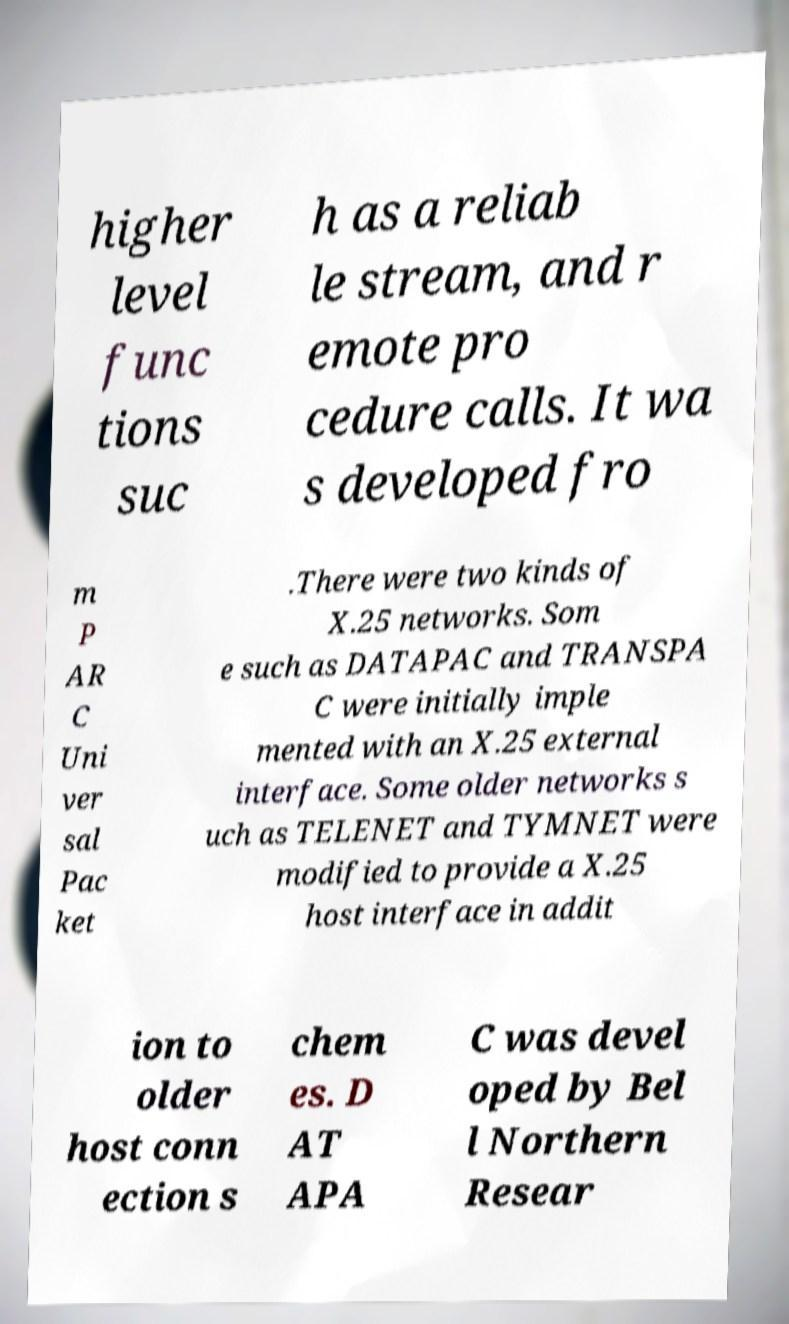Could you assist in decoding the text presented in this image and type it out clearly? higher level func tions suc h as a reliab le stream, and r emote pro cedure calls. It wa s developed fro m P AR C Uni ver sal Pac ket .There were two kinds of X.25 networks. Som e such as DATAPAC and TRANSPA C were initially imple mented with an X.25 external interface. Some older networks s uch as TELENET and TYMNET were modified to provide a X.25 host interface in addit ion to older host conn ection s chem es. D AT APA C was devel oped by Bel l Northern Resear 